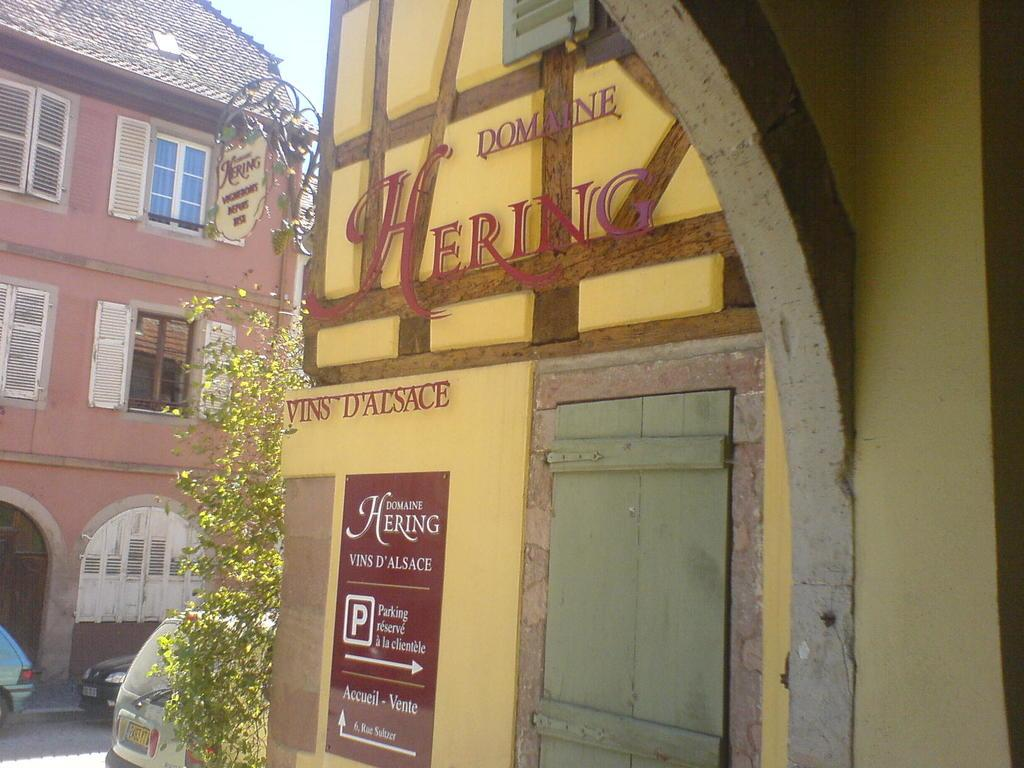What type of structures can be seen in the image? There are houses in the image. What part of the houses can be seen in the image? There are windows visible in the image. What type of vehicles are present in the image? There are cars in the image. What type of signage is present in the image? There is a poster with text in the image. What type of entrance is visible in the image? There is a door in the image. What type of plant can be seen in the image? There is a creeper plant in the image. What type of cable can be seen connecting the houses in the image? There is no cable connecting the houses in the image. How does the poster shake in the image? The poster does not shake in the image; it is stationary. 